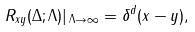Convert formula to latex. <formula><loc_0><loc_0><loc_500><loc_500>R _ { x y } ( \Delta ; \Lambda ) | _ { \, \Lambda \rightarrow \infty } = \delta ^ { d } ( x - y ) ,</formula> 